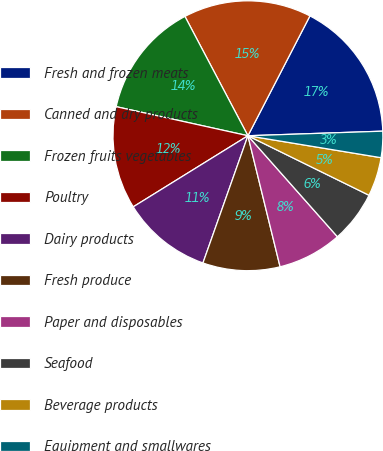<chart> <loc_0><loc_0><loc_500><loc_500><pie_chart><fcel>Fresh and frozen meats<fcel>Canned and dry products<fcel>Frozen fruits vegetables<fcel>Poultry<fcel>Dairy products<fcel>Fresh produce<fcel>Paper and disposables<fcel>Seafood<fcel>Beverage products<fcel>Equipment and smallwares<nl><fcel>16.86%<fcel>15.33%<fcel>13.81%<fcel>12.29%<fcel>10.76%<fcel>9.24%<fcel>7.71%<fcel>6.19%<fcel>4.67%<fcel>3.14%<nl></chart> 